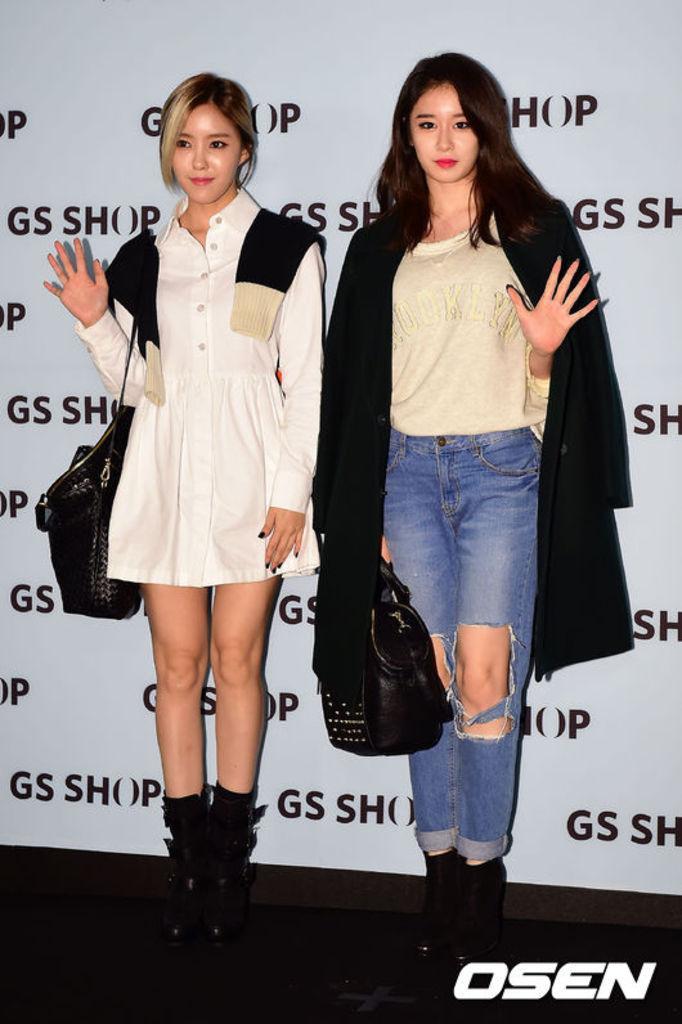Please provide a concise description of this image. In this image i can see two women standing and holding a bag,at the back ground i can a board. 